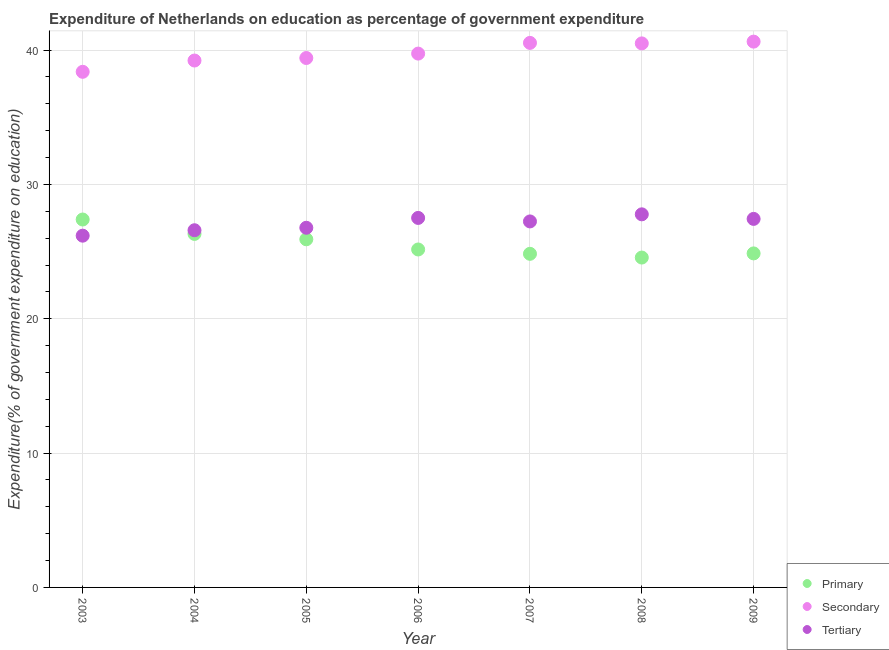Is the number of dotlines equal to the number of legend labels?
Ensure brevity in your answer.  Yes. What is the expenditure on tertiary education in 2006?
Offer a terse response. 27.51. Across all years, what is the maximum expenditure on primary education?
Offer a terse response. 27.39. Across all years, what is the minimum expenditure on secondary education?
Your response must be concise. 38.38. What is the total expenditure on secondary education in the graph?
Offer a very short reply. 278.43. What is the difference between the expenditure on secondary education in 2008 and that in 2009?
Offer a very short reply. -0.13. What is the difference between the expenditure on tertiary education in 2006 and the expenditure on primary education in 2009?
Your answer should be very brief. 2.64. What is the average expenditure on primary education per year?
Provide a succinct answer. 25.58. In the year 2007, what is the difference between the expenditure on tertiary education and expenditure on secondary education?
Your response must be concise. -13.29. In how many years, is the expenditure on secondary education greater than 24 %?
Give a very brief answer. 7. What is the ratio of the expenditure on secondary education in 2003 to that in 2008?
Offer a terse response. 0.95. What is the difference between the highest and the second highest expenditure on secondary education?
Offer a very short reply. 0.09. What is the difference between the highest and the lowest expenditure on primary education?
Offer a terse response. 2.83. In how many years, is the expenditure on primary education greater than the average expenditure on primary education taken over all years?
Give a very brief answer. 3. Is the sum of the expenditure on primary education in 2003 and 2007 greater than the maximum expenditure on secondary education across all years?
Your response must be concise. Yes. Does the expenditure on primary education monotonically increase over the years?
Offer a terse response. No. Is the expenditure on tertiary education strictly greater than the expenditure on secondary education over the years?
Provide a succinct answer. No. How many dotlines are there?
Provide a succinct answer. 3. How many years are there in the graph?
Ensure brevity in your answer.  7. What is the difference between two consecutive major ticks on the Y-axis?
Your response must be concise. 10. Does the graph contain any zero values?
Your response must be concise. No. What is the title of the graph?
Give a very brief answer. Expenditure of Netherlands on education as percentage of government expenditure. What is the label or title of the Y-axis?
Give a very brief answer. Expenditure(% of government expenditure on education). What is the Expenditure(% of government expenditure on education) of Primary in 2003?
Your answer should be very brief. 27.39. What is the Expenditure(% of government expenditure on education) of Secondary in 2003?
Your answer should be compact. 38.38. What is the Expenditure(% of government expenditure on education) in Tertiary in 2003?
Your answer should be compact. 26.19. What is the Expenditure(% of government expenditure on education) in Primary in 2004?
Provide a succinct answer. 26.32. What is the Expenditure(% of government expenditure on education) of Secondary in 2004?
Offer a very short reply. 39.22. What is the Expenditure(% of government expenditure on education) of Tertiary in 2004?
Ensure brevity in your answer.  26.59. What is the Expenditure(% of government expenditure on education) of Primary in 2005?
Your answer should be compact. 25.92. What is the Expenditure(% of government expenditure on education) of Secondary in 2005?
Offer a very short reply. 39.41. What is the Expenditure(% of government expenditure on education) of Tertiary in 2005?
Your response must be concise. 26.77. What is the Expenditure(% of government expenditure on education) of Primary in 2006?
Keep it short and to the point. 25.16. What is the Expenditure(% of government expenditure on education) in Secondary in 2006?
Make the answer very short. 39.74. What is the Expenditure(% of government expenditure on education) in Tertiary in 2006?
Your answer should be compact. 27.51. What is the Expenditure(% of government expenditure on education) in Primary in 2007?
Your response must be concise. 24.84. What is the Expenditure(% of government expenditure on education) of Secondary in 2007?
Ensure brevity in your answer.  40.54. What is the Expenditure(% of government expenditure on education) of Tertiary in 2007?
Provide a succinct answer. 27.25. What is the Expenditure(% of government expenditure on education) of Primary in 2008?
Give a very brief answer. 24.56. What is the Expenditure(% of government expenditure on education) in Secondary in 2008?
Keep it short and to the point. 40.5. What is the Expenditure(% of government expenditure on education) of Tertiary in 2008?
Your answer should be compact. 27.77. What is the Expenditure(% of government expenditure on education) in Primary in 2009?
Your response must be concise. 24.87. What is the Expenditure(% of government expenditure on education) of Secondary in 2009?
Provide a succinct answer. 40.63. What is the Expenditure(% of government expenditure on education) of Tertiary in 2009?
Provide a short and direct response. 27.43. Across all years, what is the maximum Expenditure(% of government expenditure on education) of Primary?
Give a very brief answer. 27.39. Across all years, what is the maximum Expenditure(% of government expenditure on education) in Secondary?
Your answer should be compact. 40.63. Across all years, what is the maximum Expenditure(% of government expenditure on education) of Tertiary?
Your response must be concise. 27.77. Across all years, what is the minimum Expenditure(% of government expenditure on education) of Primary?
Your response must be concise. 24.56. Across all years, what is the minimum Expenditure(% of government expenditure on education) in Secondary?
Your response must be concise. 38.38. Across all years, what is the minimum Expenditure(% of government expenditure on education) of Tertiary?
Provide a succinct answer. 26.19. What is the total Expenditure(% of government expenditure on education) in Primary in the graph?
Offer a very short reply. 179.04. What is the total Expenditure(% of government expenditure on education) of Secondary in the graph?
Ensure brevity in your answer.  278.43. What is the total Expenditure(% of government expenditure on education) in Tertiary in the graph?
Offer a very short reply. 189.51. What is the difference between the Expenditure(% of government expenditure on education) in Primary in 2003 and that in 2004?
Provide a short and direct response. 1.07. What is the difference between the Expenditure(% of government expenditure on education) of Secondary in 2003 and that in 2004?
Your response must be concise. -0.84. What is the difference between the Expenditure(% of government expenditure on education) of Tertiary in 2003 and that in 2004?
Provide a short and direct response. -0.4. What is the difference between the Expenditure(% of government expenditure on education) in Primary in 2003 and that in 2005?
Ensure brevity in your answer.  1.47. What is the difference between the Expenditure(% of government expenditure on education) in Secondary in 2003 and that in 2005?
Provide a short and direct response. -1.03. What is the difference between the Expenditure(% of government expenditure on education) in Tertiary in 2003 and that in 2005?
Give a very brief answer. -0.59. What is the difference between the Expenditure(% of government expenditure on education) of Primary in 2003 and that in 2006?
Provide a short and direct response. 2.23. What is the difference between the Expenditure(% of government expenditure on education) of Secondary in 2003 and that in 2006?
Keep it short and to the point. -1.36. What is the difference between the Expenditure(% of government expenditure on education) of Tertiary in 2003 and that in 2006?
Provide a short and direct response. -1.32. What is the difference between the Expenditure(% of government expenditure on education) of Primary in 2003 and that in 2007?
Give a very brief answer. 2.55. What is the difference between the Expenditure(% of government expenditure on education) in Secondary in 2003 and that in 2007?
Give a very brief answer. -2.15. What is the difference between the Expenditure(% of government expenditure on education) of Tertiary in 2003 and that in 2007?
Give a very brief answer. -1.06. What is the difference between the Expenditure(% of government expenditure on education) of Primary in 2003 and that in 2008?
Ensure brevity in your answer.  2.83. What is the difference between the Expenditure(% of government expenditure on education) in Secondary in 2003 and that in 2008?
Keep it short and to the point. -2.12. What is the difference between the Expenditure(% of government expenditure on education) of Tertiary in 2003 and that in 2008?
Offer a terse response. -1.59. What is the difference between the Expenditure(% of government expenditure on education) of Primary in 2003 and that in 2009?
Your answer should be compact. 2.52. What is the difference between the Expenditure(% of government expenditure on education) of Secondary in 2003 and that in 2009?
Provide a short and direct response. -2.25. What is the difference between the Expenditure(% of government expenditure on education) of Tertiary in 2003 and that in 2009?
Give a very brief answer. -1.25. What is the difference between the Expenditure(% of government expenditure on education) of Primary in 2004 and that in 2005?
Offer a very short reply. 0.4. What is the difference between the Expenditure(% of government expenditure on education) of Secondary in 2004 and that in 2005?
Ensure brevity in your answer.  -0.19. What is the difference between the Expenditure(% of government expenditure on education) of Tertiary in 2004 and that in 2005?
Make the answer very short. -0.18. What is the difference between the Expenditure(% of government expenditure on education) in Primary in 2004 and that in 2006?
Keep it short and to the point. 1.16. What is the difference between the Expenditure(% of government expenditure on education) in Secondary in 2004 and that in 2006?
Your answer should be very brief. -0.52. What is the difference between the Expenditure(% of government expenditure on education) of Tertiary in 2004 and that in 2006?
Your answer should be very brief. -0.92. What is the difference between the Expenditure(% of government expenditure on education) of Primary in 2004 and that in 2007?
Your response must be concise. 1.48. What is the difference between the Expenditure(% of government expenditure on education) of Secondary in 2004 and that in 2007?
Offer a terse response. -1.31. What is the difference between the Expenditure(% of government expenditure on education) in Tertiary in 2004 and that in 2007?
Your response must be concise. -0.66. What is the difference between the Expenditure(% of government expenditure on education) in Primary in 2004 and that in 2008?
Make the answer very short. 1.76. What is the difference between the Expenditure(% of government expenditure on education) in Secondary in 2004 and that in 2008?
Your answer should be compact. -1.28. What is the difference between the Expenditure(% of government expenditure on education) of Tertiary in 2004 and that in 2008?
Offer a very short reply. -1.18. What is the difference between the Expenditure(% of government expenditure on education) in Primary in 2004 and that in 2009?
Offer a terse response. 1.45. What is the difference between the Expenditure(% of government expenditure on education) of Secondary in 2004 and that in 2009?
Provide a succinct answer. -1.41. What is the difference between the Expenditure(% of government expenditure on education) of Tertiary in 2004 and that in 2009?
Your response must be concise. -0.84. What is the difference between the Expenditure(% of government expenditure on education) of Primary in 2005 and that in 2006?
Make the answer very short. 0.76. What is the difference between the Expenditure(% of government expenditure on education) in Secondary in 2005 and that in 2006?
Ensure brevity in your answer.  -0.33. What is the difference between the Expenditure(% of government expenditure on education) of Tertiary in 2005 and that in 2006?
Your answer should be compact. -0.73. What is the difference between the Expenditure(% of government expenditure on education) of Primary in 2005 and that in 2007?
Your response must be concise. 1.08. What is the difference between the Expenditure(% of government expenditure on education) of Secondary in 2005 and that in 2007?
Your response must be concise. -1.12. What is the difference between the Expenditure(% of government expenditure on education) in Tertiary in 2005 and that in 2007?
Your response must be concise. -0.47. What is the difference between the Expenditure(% of government expenditure on education) in Primary in 2005 and that in 2008?
Ensure brevity in your answer.  1.36. What is the difference between the Expenditure(% of government expenditure on education) in Secondary in 2005 and that in 2008?
Your answer should be very brief. -1.09. What is the difference between the Expenditure(% of government expenditure on education) of Tertiary in 2005 and that in 2008?
Provide a succinct answer. -1. What is the difference between the Expenditure(% of government expenditure on education) in Primary in 2005 and that in 2009?
Provide a short and direct response. 1.05. What is the difference between the Expenditure(% of government expenditure on education) of Secondary in 2005 and that in 2009?
Keep it short and to the point. -1.22. What is the difference between the Expenditure(% of government expenditure on education) of Tertiary in 2005 and that in 2009?
Your answer should be very brief. -0.66. What is the difference between the Expenditure(% of government expenditure on education) in Primary in 2006 and that in 2007?
Offer a terse response. 0.32. What is the difference between the Expenditure(% of government expenditure on education) of Secondary in 2006 and that in 2007?
Keep it short and to the point. -0.8. What is the difference between the Expenditure(% of government expenditure on education) of Tertiary in 2006 and that in 2007?
Your answer should be very brief. 0.26. What is the difference between the Expenditure(% of government expenditure on education) of Primary in 2006 and that in 2008?
Your response must be concise. 0.6. What is the difference between the Expenditure(% of government expenditure on education) of Secondary in 2006 and that in 2008?
Make the answer very short. -0.76. What is the difference between the Expenditure(% of government expenditure on education) in Tertiary in 2006 and that in 2008?
Your answer should be very brief. -0.27. What is the difference between the Expenditure(% of government expenditure on education) of Primary in 2006 and that in 2009?
Provide a succinct answer. 0.29. What is the difference between the Expenditure(% of government expenditure on education) of Secondary in 2006 and that in 2009?
Give a very brief answer. -0.89. What is the difference between the Expenditure(% of government expenditure on education) of Tertiary in 2006 and that in 2009?
Your response must be concise. 0.07. What is the difference between the Expenditure(% of government expenditure on education) in Primary in 2007 and that in 2008?
Your answer should be compact. 0.28. What is the difference between the Expenditure(% of government expenditure on education) of Secondary in 2007 and that in 2008?
Make the answer very short. 0.04. What is the difference between the Expenditure(% of government expenditure on education) of Tertiary in 2007 and that in 2008?
Keep it short and to the point. -0.53. What is the difference between the Expenditure(% of government expenditure on education) of Primary in 2007 and that in 2009?
Make the answer very short. -0.03. What is the difference between the Expenditure(% of government expenditure on education) of Secondary in 2007 and that in 2009?
Your answer should be very brief. -0.09. What is the difference between the Expenditure(% of government expenditure on education) in Tertiary in 2007 and that in 2009?
Offer a very short reply. -0.19. What is the difference between the Expenditure(% of government expenditure on education) in Primary in 2008 and that in 2009?
Offer a very short reply. -0.31. What is the difference between the Expenditure(% of government expenditure on education) of Secondary in 2008 and that in 2009?
Offer a terse response. -0.13. What is the difference between the Expenditure(% of government expenditure on education) in Tertiary in 2008 and that in 2009?
Provide a succinct answer. 0.34. What is the difference between the Expenditure(% of government expenditure on education) of Primary in 2003 and the Expenditure(% of government expenditure on education) of Secondary in 2004?
Your answer should be very brief. -11.84. What is the difference between the Expenditure(% of government expenditure on education) in Primary in 2003 and the Expenditure(% of government expenditure on education) in Tertiary in 2004?
Provide a short and direct response. 0.8. What is the difference between the Expenditure(% of government expenditure on education) in Secondary in 2003 and the Expenditure(% of government expenditure on education) in Tertiary in 2004?
Offer a terse response. 11.79. What is the difference between the Expenditure(% of government expenditure on education) in Primary in 2003 and the Expenditure(% of government expenditure on education) in Secondary in 2005?
Your answer should be very brief. -12.02. What is the difference between the Expenditure(% of government expenditure on education) in Primary in 2003 and the Expenditure(% of government expenditure on education) in Tertiary in 2005?
Ensure brevity in your answer.  0.61. What is the difference between the Expenditure(% of government expenditure on education) in Secondary in 2003 and the Expenditure(% of government expenditure on education) in Tertiary in 2005?
Provide a short and direct response. 11.61. What is the difference between the Expenditure(% of government expenditure on education) in Primary in 2003 and the Expenditure(% of government expenditure on education) in Secondary in 2006?
Offer a terse response. -12.35. What is the difference between the Expenditure(% of government expenditure on education) of Primary in 2003 and the Expenditure(% of government expenditure on education) of Tertiary in 2006?
Your response must be concise. -0.12. What is the difference between the Expenditure(% of government expenditure on education) of Secondary in 2003 and the Expenditure(% of government expenditure on education) of Tertiary in 2006?
Your answer should be compact. 10.88. What is the difference between the Expenditure(% of government expenditure on education) of Primary in 2003 and the Expenditure(% of government expenditure on education) of Secondary in 2007?
Make the answer very short. -13.15. What is the difference between the Expenditure(% of government expenditure on education) in Primary in 2003 and the Expenditure(% of government expenditure on education) in Tertiary in 2007?
Make the answer very short. 0.14. What is the difference between the Expenditure(% of government expenditure on education) in Secondary in 2003 and the Expenditure(% of government expenditure on education) in Tertiary in 2007?
Provide a short and direct response. 11.14. What is the difference between the Expenditure(% of government expenditure on education) of Primary in 2003 and the Expenditure(% of government expenditure on education) of Secondary in 2008?
Keep it short and to the point. -13.11. What is the difference between the Expenditure(% of government expenditure on education) of Primary in 2003 and the Expenditure(% of government expenditure on education) of Tertiary in 2008?
Provide a succinct answer. -0.39. What is the difference between the Expenditure(% of government expenditure on education) in Secondary in 2003 and the Expenditure(% of government expenditure on education) in Tertiary in 2008?
Your response must be concise. 10.61. What is the difference between the Expenditure(% of government expenditure on education) of Primary in 2003 and the Expenditure(% of government expenditure on education) of Secondary in 2009?
Your answer should be very brief. -13.24. What is the difference between the Expenditure(% of government expenditure on education) in Primary in 2003 and the Expenditure(% of government expenditure on education) in Tertiary in 2009?
Keep it short and to the point. -0.05. What is the difference between the Expenditure(% of government expenditure on education) in Secondary in 2003 and the Expenditure(% of government expenditure on education) in Tertiary in 2009?
Ensure brevity in your answer.  10.95. What is the difference between the Expenditure(% of government expenditure on education) in Primary in 2004 and the Expenditure(% of government expenditure on education) in Secondary in 2005?
Ensure brevity in your answer.  -13.1. What is the difference between the Expenditure(% of government expenditure on education) in Primary in 2004 and the Expenditure(% of government expenditure on education) in Tertiary in 2005?
Provide a short and direct response. -0.46. What is the difference between the Expenditure(% of government expenditure on education) in Secondary in 2004 and the Expenditure(% of government expenditure on education) in Tertiary in 2005?
Ensure brevity in your answer.  12.45. What is the difference between the Expenditure(% of government expenditure on education) of Primary in 2004 and the Expenditure(% of government expenditure on education) of Secondary in 2006?
Ensure brevity in your answer.  -13.42. What is the difference between the Expenditure(% of government expenditure on education) in Primary in 2004 and the Expenditure(% of government expenditure on education) in Tertiary in 2006?
Offer a terse response. -1.19. What is the difference between the Expenditure(% of government expenditure on education) in Secondary in 2004 and the Expenditure(% of government expenditure on education) in Tertiary in 2006?
Your response must be concise. 11.72. What is the difference between the Expenditure(% of government expenditure on education) of Primary in 2004 and the Expenditure(% of government expenditure on education) of Secondary in 2007?
Your response must be concise. -14.22. What is the difference between the Expenditure(% of government expenditure on education) of Primary in 2004 and the Expenditure(% of government expenditure on education) of Tertiary in 2007?
Give a very brief answer. -0.93. What is the difference between the Expenditure(% of government expenditure on education) of Secondary in 2004 and the Expenditure(% of government expenditure on education) of Tertiary in 2007?
Your answer should be very brief. 11.98. What is the difference between the Expenditure(% of government expenditure on education) in Primary in 2004 and the Expenditure(% of government expenditure on education) in Secondary in 2008?
Make the answer very short. -14.18. What is the difference between the Expenditure(% of government expenditure on education) of Primary in 2004 and the Expenditure(% of government expenditure on education) of Tertiary in 2008?
Ensure brevity in your answer.  -1.46. What is the difference between the Expenditure(% of government expenditure on education) in Secondary in 2004 and the Expenditure(% of government expenditure on education) in Tertiary in 2008?
Give a very brief answer. 11.45. What is the difference between the Expenditure(% of government expenditure on education) in Primary in 2004 and the Expenditure(% of government expenditure on education) in Secondary in 2009?
Keep it short and to the point. -14.31. What is the difference between the Expenditure(% of government expenditure on education) of Primary in 2004 and the Expenditure(% of government expenditure on education) of Tertiary in 2009?
Keep it short and to the point. -1.12. What is the difference between the Expenditure(% of government expenditure on education) of Secondary in 2004 and the Expenditure(% of government expenditure on education) of Tertiary in 2009?
Make the answer very short. 11.79. What is the difference between the Expenditure(% of government expenditure on education) of Primary in 2005 and the Expenditure(% of government expenditure on education) of Secondary in 2006?
Offer a terse response. -13.82. What is the difference between the Expenditure(% of government expenditure on education) of Primary in 2005 and the Expenditure(% of government expenditure on education) of Tertiary in 2006?
Your response must be concise. -1.59. What is the difference between the Expenditure(% of government expenditure on education) in Secondary in 2005 and the Expenditure(% of government expenditure on education) in Tertiary in 2006?
Give a very brief answer. 11.9. What is the difference between the Expenditure(% of government expenditure on education) of Primary in 2005 and the Expenditure(% of government expenditure on education) of Secondary in 2007?
Offer a terse response. -14.62. What is the difference between the Expenditure(% of government expenditure on education) in Primary in 2005 and the Expenditure(% of government expenditure on education) in Tertiary in 2007?
Your answer should be very brief. -1.33. What is the difference between the Expenditure(% of government expenditure on education) in Secondary in 2005 and the Expenditure(% of government expenditure on education) in Tertiary in 2007?
Your response must be concise. 12.17. What is the difference between the Expenditure(% of government expenditure on education) in Primary in 2005 and the Expenditure(% of government expenditure on education) in Secondary in 2008?
Your answer should be compact. -14.58. What is the difference between the Expenditure(% of government expenditure on education) in Primary in 2005 and the Expenditure(% of government expenditure on education) in Tertiary in 2008?
Offer a very short reply. -1.86. What is the difference between the Expenditure(% of government expenditure on education) in Secondary in 2005 and the Expenditure(% of government expenditure on education) in Tertiary in 2008?
Provide a succinct answer. 11.64. What is the difference between the Expenditure(% of government expenditure on education) in Primary in 2005 and the Expenditure(% of government expenditure on education) in Secondary in 2009?
Give a very brief answer. -14.71. What is the difference between the Expenditure(% of government expenditure on education) of Primary in 2005 and the Expenditure(% of government expenditure on education) of Tertiary in 2009?
Your answer should be compact. -1.52. What is the difference between the Expenditure(% of government expenditure on education) of Secondary in 2005 and the Expenditure(% of government expenditure on education) of Tertiary in 2009?
Give a very brief answer. 11.98. What is the difference between the Expenditure(% of government expenditure on education) in Primary in 2006 and the Expenditure(% of government expenditure on education) in Secondary in 2007?
Ensure brevity in your answer.  -15.38. What is the difference between the Expenditure(% of government expenditure on education) in Primary in 2006 and the Expenditure(% of government expenditure on education) in Tertiary in 2007?
Give a very brief answer. -2.09. What is the difference between the Expenditure(% of government expenditure on education) of Secondary in 2006 and the Expenditure(% of government expenditure on education) of Tertiary in 2007?
Your answer should be very brief. 12.49. What is the difference between the Expenditure(% of government expenditure on education) in Primary in 2006 and the Expenditure(% of government expenditure on education) in Secondary in 2008?
Make the answer very short. -15.34. What is the difference between the Expenditure(% of government expenditure on education) of Primary in 2006 and the Expenditure(% of government expenditure on education) of Tertiary in 2008?
Provide a short and direct response. -2.62. What is the difference between the Expenditure(% of government expenditure on education) in Secondary in 2006 and the Expenditure(% of government expenditure on education) in Tertiary in 2008?
Make the answer very short. 11.97. What is the difference between the Expenditure(% of government expenditure on education) of Primary in 2006 and the Expenditure(% of government expenditure on education) of Secondary in 2009?
Provide a succinct answer. -15.47. What is the difference between the Expenditure(% of government expenditure on education) in Primary in 2006 and the Expenditure(% of government expenditure on education) in Tertiary in 2009?
Your answer should be very brief. -2.28. What is the difference between the Expenditure(% of government expenditure on education) of Secondary in 2006 and the Expenditure(% of government expenditure on education) of Tertiary in 2009?
Offer a terse response. 12.31. What is the difference between the Expenditure(% of government expenditure on education) of Primary in 2007 and the Expenditure(% of government expenditure on education) of Secondary in 2008?
Make the answer very short. -15.66. What is the difference between the Expenditure(% of government expenditure on education) in Primary in 2007 and the Expenditure(% of government expenditure on education) in Tertiary in 2008?
Make the answer very short. -2.94. What is the difference between the Expenditure(% of government expenditure on education) of Secondary in 2007 and the Expenditure(% of government expenditure on education) of Tertiary in 2008?
Offer a terse response. 12.76. What is the difference between the Expenditure(% of government expenditure on education) in Primary in 2007 and the Expenditure(% of government expenditure on education) in Secondary in 2009?
Your answer should be very brief. -15.8. What is the difference between the Expenditure(% of government expenditure on education) in Primary in 2007 and the Expenditure(% of government expenditure on education) in Tertiary in 2009?
Provide a short and direct response. -2.6. What is the difference between the Expenditure(% of government expenditure on education) in Secondary in 2007 and the Expenditure(% of government expenditure on education) in Tertiary in 2009?
Provide a succinct answer. 13.1. What is the difference between the Expenditure(% of government expenditure on education) of Primary in 2008 and the Expenditure(% of government expenditure on education) of Secondary in 2009?
Your response must be concise. -16.07. What is the difference between the Expenditure(% of government expenditure on education) of Primary in 2008 and the Expenditure(% of government expenditure on education) of Tertiary in 2009?
Offer a terse response. -2.88. What is the difference between the Expenditure(% of government expenditure on education) in Secondary in 2008 and the Expenditure(% of government expenditure on education) in Tertiary in 2009?
Ensure brevity in your answer.  13.07. What is the average Expenditure(% of government expenditure on education) of Primary per year?
Your response must be concise. 25.58. What is the average Expenditure(% of government expenditure on education) of Secondary per year?
Your answer should be very brief. 39.78. What is the average Expenditure(% of government expenditure on education) of Tertiary per year?
Offer a very short reply. 27.07. In the year 2003, what is the difference between the Expenditure(% of government expenditure on education) of Primary and Expenditure(% of government expenditure on education) of Secondary?
Ensure brevity in your answer.  -11. In the year 2003, what is the difference between the Expenditure(% of government expenditure on education) in Primary and Expenditure(% of government expenditure on education) in Tertiary?
Your answer should be compact. 1.2. In the year 2003, what is the difference between the Expenditure(% of government expenditure on education) in Secondary and Expenditure(% of government expenditure on education) in Tertiary?
Give a very brief answer. 12.2. In the year 2004, what is the difference between the Expenditure(% of government expenditure on education) in Primary and Expenditure(% of government expenditure on education) in Secondary?
Ensure brevity in your answer.  -12.91. In the year 2004, what is the difference between the Expenditure(% of government expenditure on education) in Primary and Expenditure(% of government expenditure on education) in Tertiary?
Your answer should be compact. -0.27. In the year 2004, what is the difference between the Expenditure(% of government expenditure on education) of Secondary and Expenditure(% of government expenditure on education) of Tertiary?
Provide a succinct answer. 12.63. In the year 2005, what is the difference between the Expenditure(% of government expenditure on education) of Primary and Expenditure(% of government expenditure on education) of Secondary?
Ensure brevity in your answer.  -13.5. In the year 2005, what is the difference between the Expenditure(% of government expenditure on education) of Primary and Expenditure(% of government expenditure on education) of Tertiary?
Give a very brief answer. -0.86. In the year 2005, what is the difference between the Expenditure(% of government expenditure on education) of Secondary and Expenditure(% of government expenditure on education) of Tertiary?
Offer a very short reply. 12.64. In the year 2006, what is the difference between the Expenditure(% of government expenditure on education) of Primary and Expenditure(% of government expenditure on education) of Secondary?
Ensure brevity in your answer.  -14.58. In the year 2006, what is the difference between the Expenditure(% of government expenditure on education) of Primary and Expenditure(% of government expenditure on education) of Tertiary?
Your answer should be compact. -2.35. In the year 2006, what is the difference between the Expenditure(% of government expenditure on education) of Secondary and Expenditure(% of government expenditure on education) of Tertiary?
Provide a succinct answer. 12.23. In the year 2007, what is the difference between the Expenditure(% of government expenditure on education) in Primary and Expenditure(% of government expenditure on education) in Secondary?
Ensure brevity in your answer.  -15.7. In the year 2007, what is the difference between the Expenditure(% of government expenditure on education) of Primary and Expenditure(% of government expenditure on education) of Tertiary?
Give a very brief answer. -2.41. In the year 2007, what is the difference between the Expenditure(% of government expenditure on education) in Secondary and Expenditure(% of government expenditure on education) in Tertiary?
Provide a short and direct response. 13.29. In the year 2008, what is the difference between the Expenditure(% of government expenditure on education) of Primary and Expenditure(% of government expenditure on education) of Secondary?
Your answer should be compact. -15.94. In the year 2008, what is the difference between the Expenditure(% of government expenditure on education) in Primary and Expenditure(% of government expenditure on education) in Tertiary?
Give a very brief answer. -3.22. In the year 2008, what is the difference between the Expenditure(% of government expenditure on education) of Secondary and Expenditure(% of government expenditure on education) of Tertiary?
Give a very brief answer. 12.72. In the year 2009, what is the difference between the Expenditure(% of government expenditure on education) in Primary and Expenditure(% of government expenditure on education) in Secondary?
Your answer should be compact. -15.77. In the year 2009, what is the difference between the Expenditure(% of government expenditure on education) of Primary and Expenditure(% of government expenditure on education) of Tertiary?
Your answer should be compact. -2.57. In the year 2009, what is the difference between the Expenditure(% of government expenditure on education) in Secondary and Expenditure(% of government expenditure on education) in Tertiary?
Keep it short and to the point. 13.2. What is the ratio of the Expenditure(% of government expenditure on education) of Primary in 2003 to that in 2004?
Your answer should be compact. 1.04. What is the ratio of the Expenditure(% of government expenditure on education) of Secondary in 2003 to that in 2004?
Offer a terse response. 0.98. What is the ratio of the Expenditure(% of government expenditure on education) in Primary in 2003 to that in 2005?
Keep it short and to the point. 1.06. What is the ratio of the Expenditure(% of government expenditure on education) of Secondary in 2003 to that in 2005?
Keep it short and to the point. 0.97. What is the ratio of the Expenditure(% of government expenditure on education) in Primary in 2003 to that in 2006?
Make the answer very short. 1.09. What is the ratio of the Expenditure(% of government expenditure on education) in Secondary in 2003 to that in 2006?
Ensure brevity in your answer.  0.97. What is the ratio of the Expenditure(% of government expenditure on education) of Tertiary in 2003 to that in 2006?
Ensure brevity in your answer.  0.95. What is the ratio of the Expenditure(% of government expenditure on education) of Primary in 2003 to that in 2007?
Keep it short and to the point. 1.1. What is the ratio of the Expenditure(% of government expenditure on education) in Secondary in 2003 to that in 2007?
Offer a terse response. 0.95. What is the ratio of the Expenditure(% of government expenditure on education) of Tertiary in 2003 to that in 2007?
Your response must be concise. 0.96. What is the ratio of the Expenditure(% of government expenditure on education) in Primary in 2003 to that in 2008?
Your answer should be very brief. 1.12. What is the ratio of the Expenditure(% of government expenditure on education) of Secondary in 2003 to that in 2008?
Ensure brevity in your answer.  0.95. What is the ratio of the Expenditure(% of government expenditure on education) in Tertiary in 2003 to that in 2008?
Offer a very short reply. 0.94. What is the ratio of the Expenditure(% of government expenditure on education) of Primary in 2003 to that in 2009?
Your answer should be very brief. 1.1. What is the ratio of the Expenditure(% of government expenditure on education) of Secondary in 2003 to that in 2009?
Make the answer very short. 0.94. What is the ratio of the Expenditure(% of government expenditure on education) of Tertiary in 2003 to that in 2009?
Provide a succinct answer. 0.95. What is the ratio of the Expenditure(% of government expenditure on education) in Primary in 2004 to that in 2005?
Offer a very short reply. 1.02. What is the ratio of the Expenditure(% of government expenditure on education) of Tertiary in 2004 to that in 2005?
Your response must be concise. 0.99. What is the ratio of the Expenditure(% of government expenditure on education) in Primary in 2004 to that in 2006?
Your response must be concise. 1.05. What is the ratio of the Expenditure(% of government expenditure on education) in Tertiary in 2004 to that in 2006?
Your answer should be compact. 0.97. What is the ratio of the Expenditure(% of government expenditure on education) in Primary in 2004 to that in 2007?
Keep it short and to the point. 1.06. What is the ratio of the Expenditure(% of government expenditure on education) of Secondary in 2004 to that in 2007?
Make the answer very short. 0.97. What is the ratio of the Expenditure(% of government expenditure on education) of Tertiary in 2004 to that in 2007?
Your response must be concise. 0.98. What is the ratio of the Expenditure(% of government expenditure on education) in Primary in 2004 to that in 2008?
Offer a very short reply. 1.07. What is the ratio of the Expenditure(% of government expenditure on education) in Secondary in 2004 to that in 2008?
Keep it short and to the point. 0.97. What is the ratio of the Expenditure(% of government expenditure on education) in Tertiary in 2004 to that in 2008?
Ensure brevity in your answer.  0.96. What is the ratio of the Expenditure(% of government expenditure on education) in Primary in 2004 to that in 2009?
Keep it short and to the point. 1.06. What is the ratio of the Expenditure(% of government expenditure on education) of Secondary in 2004 to that in 2009?
Your answer should be compact. 0.97. What is the ratio of the Expenditure(% of government expenditure on education) in Tertiary in 2004 to that in 2009?
Offer a very short reply. 0.97. What is the ratio of the Expenditure(% of government expenditure on education) in Primary in 2005 to that in 2006?
Make the answer very short. 1.03. What is the ratio of the Expenditure(% of government expenditure on education) of Secondary in 2005 to that in 2006?
Ensure brevity in your answer.  0.99. What is the ratio of the Expenditure(% of government expenditure on education) of Tertiary in 2005 to that in 2006?
Ensure brevity in your answer.  0.97. What is the ratio of the Expenditure(% of government expenditure on education) in Primary in 2005 to that in 2007?
Your response must be concise. 1.04. What is the ratio of the Expenditure(% of government expenditure on education) of Secondary in 2005 to that in 2007?
Give a very brief answer. 0.97. What is the ratio of the Expenditure(% of government expenditure on education) of Tertiary in 2005 to that in 2007?
Offer a terse response. 0.98. What is the ratio of the Expenditure(% of government expenditure on education) in Primary in 2005 to that in 2008?
Provide a succinct answer. 1.06. What is the ratio of the Expenditure(% of government expenditure on education) in Secondary in 2005 to that in 2008?
Your answer should be very brief. 0.97. What is the ratio of the Expenditure(% of government expenditure on education) of Primary in 2005 to that in 2009?
Give a very brief answer. 1.04. What is the ratio of the Expenditure(% of government expenditure on education) in Secondary in 2005 to that in 2009?
Offer a very short reply. 0.97. What is the ratio of the Expenditure(% of government expenditure on education) in Tertiary in 2005 to that in 2009?
Keep it short and to the point. 0.98. What is the ratio of the Expenditure(% of government expenditure on education) in Secondary in 2006 to that in 2007?
Your answer should be compact. 0.98. What is the ratio of the Expenditure(% of government expenditure on education) in Tertiary in 2006 to that in 2007?
Your response must be concise. 1.01. What is the ratio of the Expenditure(% of government expenditure on education) of Primary in 2006 to that in 2008?
Provide a succinct answer. 1.02. What is the ratio of the Expenditure(% of government expenditure on education) of Secondary in 2006 to that in 2008?
Your answer should be compact. 0.98. What is the ratio of the Expenditure(% of government expenditure on education) in Primary in 2006 to that in 2009?
Give a very brief answer. 1.01. What is the ratio of the Expenditure(% of government expenditure on education) of Secondary in 2006 to that in 2009?
Your answer should be compact. 0.98. What is the ratio of the Expenditure(% of government expenditure on education) of Tertiary in 2006 to that in 2009?
Provide a succinct answer. 1. What is the ratio of the Expenditure(% of government expenditure on education) in Primary in 2007 to that in 2008?
Ensure brevity in your answer.  1.01. What is the ratio of the Expenditure(% of government expenditure on education) of Tertiary in 2007 to that in 2008?
Make the answer very short. 0.98. What is the ratio of the Expenditure(% of government expenditure on education) in Primary in 2007 to that in 2009?
Offer a very short reply. 1. What is the ratio of the Expenditure(% of government expenditure on education) of Tertiary in 2007 to that in 2009?
Keep it short and to the point. 0.99. What is the ratio of the Expenditure(% of government expenditure on education) in Primary in 2008 to that in 2009?
Your response must be concise. 0.99. What is the ratio of the Expenditure(% of government expenditure on education) of Secondary in 2008 to that in 2009?
Your response must be concise. 1. What is the ratio of the Expenditure(% of government expenditure on education) in Tertiary in 2008 to that in 2009?
Offer a terse response. 1.01. What is the difference between the highest and the second highest Expenditure(% of government expenditure on education) in Primary?
Ensure brevity in your answer.  1.07. What is the difference between the highest and the second highest Expenditure(% of government expenditure on education) in Secondary?
Offer a very short reply. 0.09. What is the difference between the highest and the second highest Expenditure(% of government expenditure on education) in Tertiary?
Provide a short and direct response. 0.27. What is the difference between the highest and the lowest Expenditure(% of government expenditure on education) in Primary?
Your response must be concise. 2.83. What is the difference between the highest and the lowest Expenditure(% of government expenditure on education) of Secondary?
Your answer should be very brief. 2.25. What is the difference between the highest and the lowest Expenditure(% of government expenditure on education) of Tertiary?
Give a very brief answer. 1.59. 